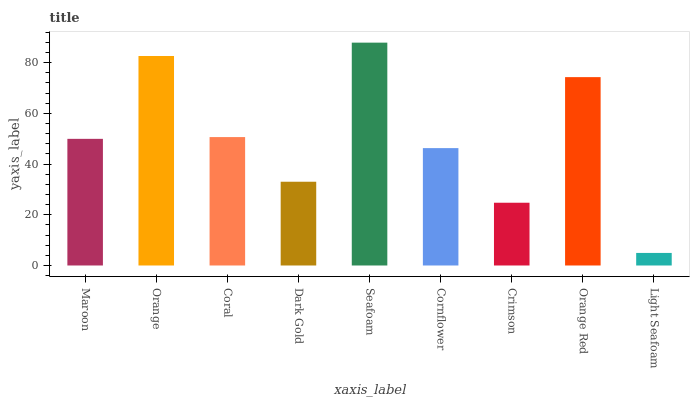Is Light Seafoam the minimum?
Answer yes or no. Yes. Is Seafoam the maximum?
Answer yes or no. Yes. Is Orange the minimum?
Answer yes or no. No. Is Orange the maximum?
Answer yes or no. No. Is Orange greater than Maroon?
Answer yes or no. Yes. Is Maroon less than Orange?
Answer yes or no. Yes. Is Maroon greater than Orange?
Answer yes or no. No. Is Orange less than Maroon?
Answer yes or no. No. Is Maroon the high median?
Answer yes or no. Yes. Is Maroon the low median?
Answer yes or no. Yes. Is Orange the high median?
Answer yes or no. No. Is Coral the low median?
Answer yes or no. No. 